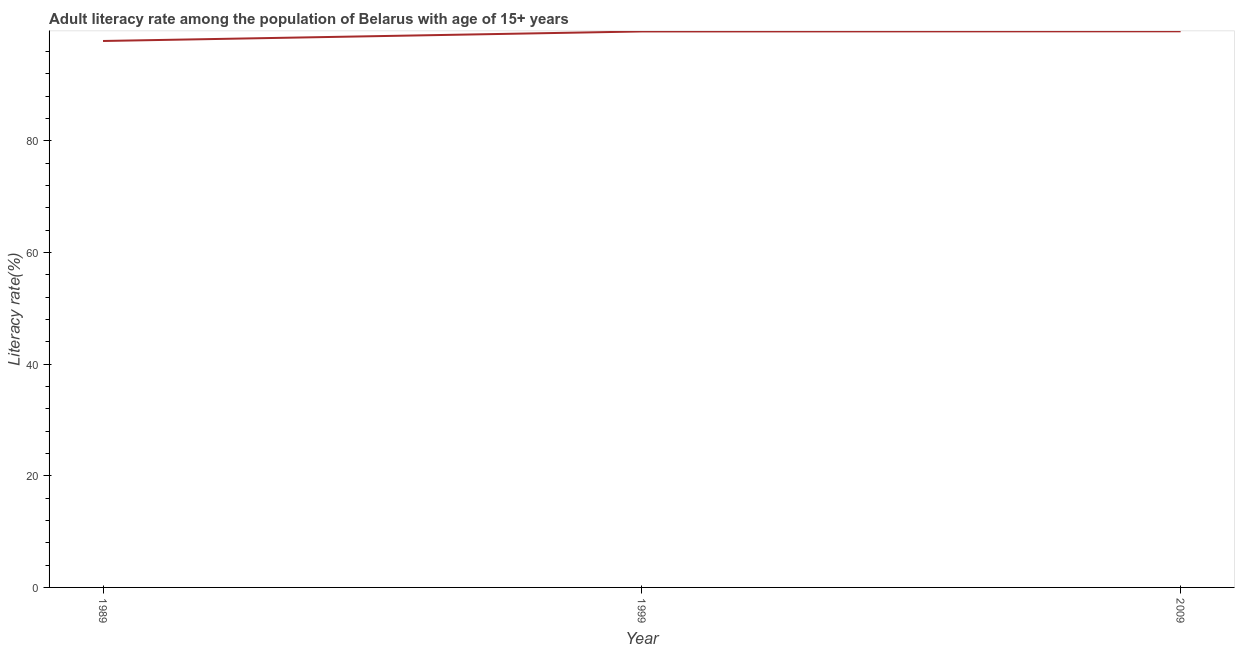What is the adult literacy rate in 2009?
Provide a succinct answer. 99.62. Across all years, what is the maximum adult literacy rate?
Provide a short and direct response. 99.62. Across all years, what is the minimum adult literacy rate?
Ensure brevity in your answer.  97.88. In which year was the adult literacy rate maximum?
Provide a succinct answer. 2009. What is the sum of the adult literacy rate?
Offer a very short reply. 297.09. What is the difference between the adult literacy rate in 1989 and 2009?
Ensure brevity in your answer.  -1.73. What is the average adult literacy rate per year?
Ensure brevity in your answer.  99.03. What is the median adult literacy rate?
Offer a very short reply. 99.59. What is the ratio of the adult literacy rate in 1989 to that in 2009?
Give a very brief answer. 0.98. Is the adult literacy rate in 1999 less than that in 2009?
Your answer should be compact. Yes. Is the difference between the adult literacy rate in 1989 and 2009 greater than the difference between any two years?
Provide a succinct answer. Yes. What is the difference between the highest and the second highest adult literacy rate?
Provide a succinct answer. 0.03. What is the difference between the highest and the lowest adult literacy rate?
Provide a short and direct response. 1.73. In how many years, is the adult literacy rate greater than the average adult literacy rate taken over all years?
Provide a succinct answer. 2. Does the adult literacy rate monotonically increase over the years?
Offer a very short reply. Yes. How many lines are there?
Make the answer very short. 1. What is the difference between two consecutive major ticks on the Y-axis?
Make the answer very short. 20. Are the values on the major ticks of Y-axis written in scientific E-notation?
Make the answer very short. No. What is the title of the graph?
Make the answer very short. Adult literacy rate among the population of Belarus with age of 15+ years. What is the label or title of the Y-axis?
Your answer should be very brief. Literacy rate(%). What is the Literacy rate(%) in 1989?
Provide a succinct answer. 97.88. What is the Literacy rate(%) of 1999?
Your response must be concise. 99.59. What is the Literacy rate(%) of 2009?
Keep it short and to the point. 99.62. What is the difference between the Literacy rate(%) in 1989 and 1999?
Offer a terse response. -1.71. What is the difference between the Literacy rate(%) in 1989 and 2009?
Your answer should be compact. -1.73. What is the difference between the Literacy rate(%) in 1999 and 2009?
Keep it short and to the point. -0.03. What is the ratio of the Literacy rate(%) in 1989 to that in 1999?
Keep it short and to the point. 0.98. 